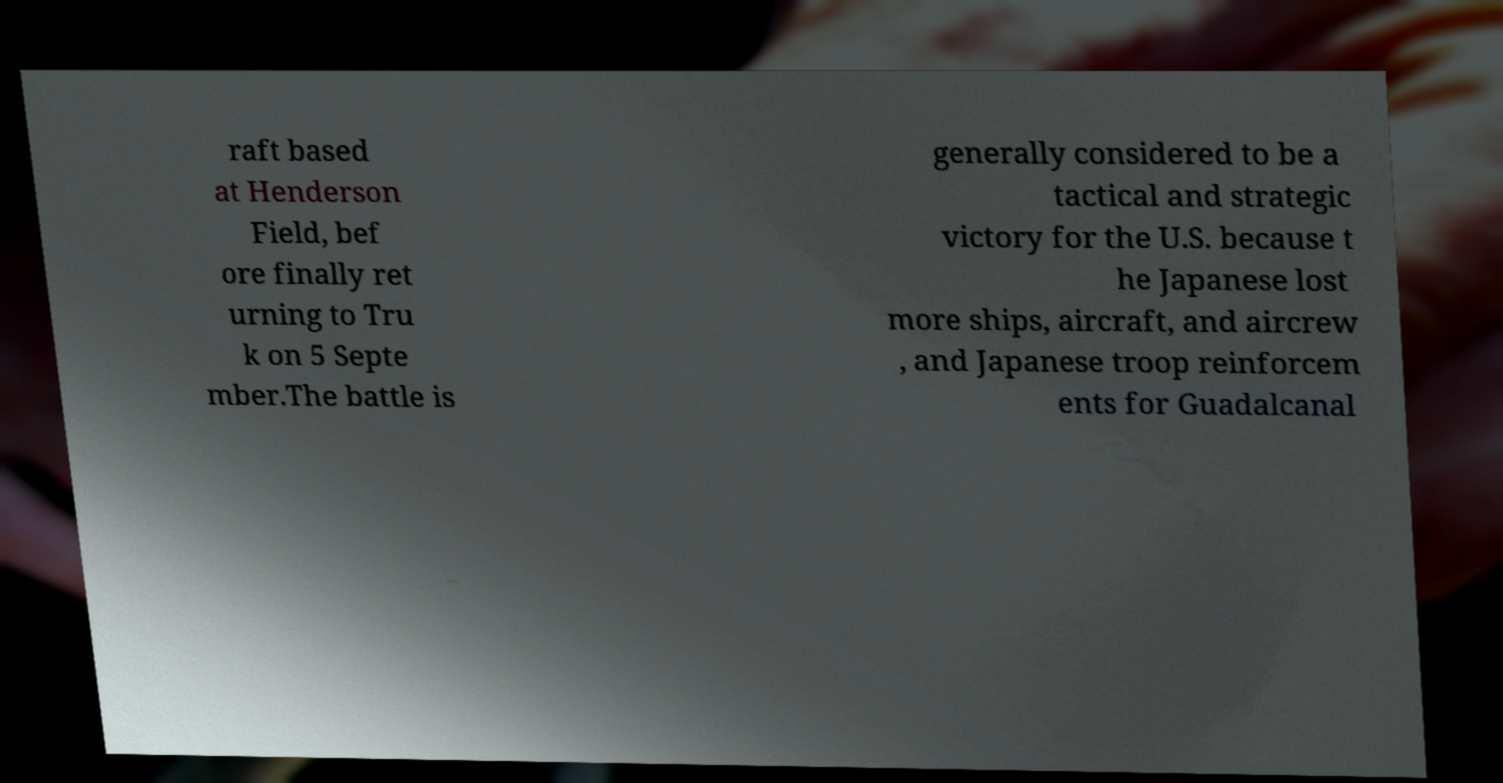Please read and relay the text visible in this image. What does it say? raft based at Henderson Field, bef ore finally ret urning to Tru k on 5 Septe mber.The battle is generally considered to be a tactical and strategic victory for the U.S. because t he Japanese lost more ships, aircraft, and aircrew , and Japanese troop reinforcem ents for Guadalcanal 